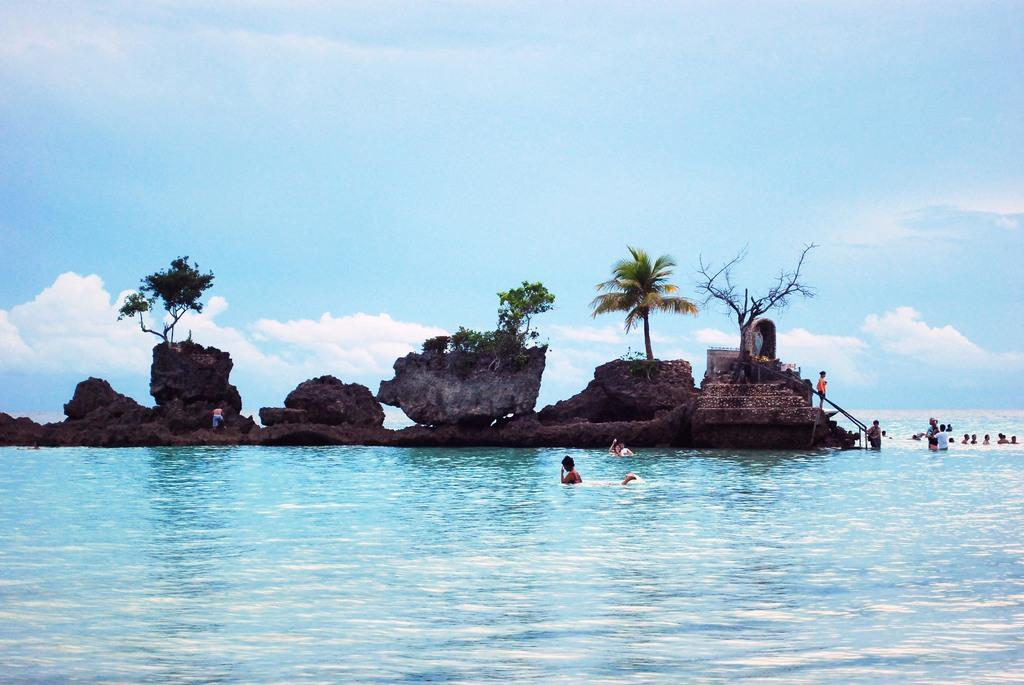What are the people in the image doing in the water? Some people are standing in the water, while others are swimming in the water. What can be seen on the island in the image? There are trees and plants on the island in the image. What is visible in the background of the image? The sky is visible in the background of the image. How many eggs are present on the island in the image? There is no mention of eggs in the image; the island has trees and plants. 